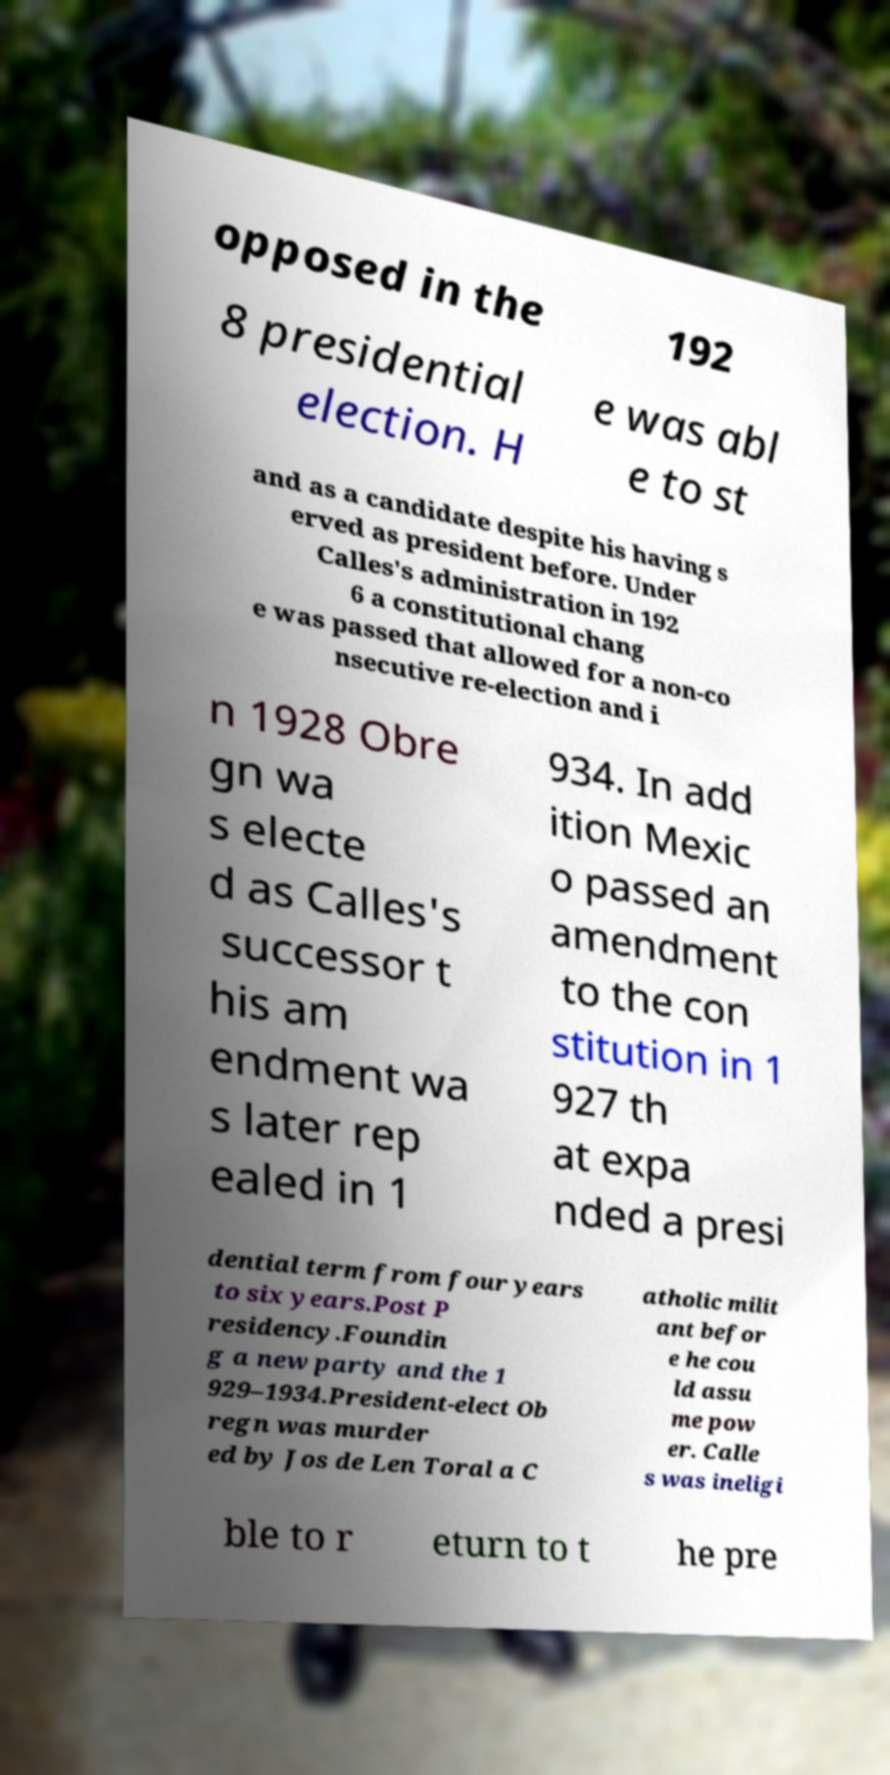Can you read and provide the text displayed in the image?This photo seems to have some interesting text. Can you extract and type it out for me? opposed in the 192 8 presidential election. H e was abl e to st and as a candidate despite his having s erved as president before. Under Calles's administration in 192 6 a constitutional chang e was passed that allowed for a non-co nsecutive re-election and i n 1928 Obre gn wa s electe d as Calles's successor t his am endment wa s later rep ealed in 1 934. In add ition Mexic o passed an amendment to the con stitution in 1 927 th at expa nded a presi dential term from four years to six years.Post P residency.Foundin g a new party and the 1 929–1934.President-elect Ob regn was murder ed by Jos de Len Toral a C atholic milit ant befor e he cou ld assu me pow er. Calle s was ineligi ble to r eturn to t he pre 